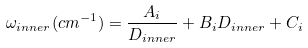Convert formula to latex. <formula><loc_0><loc_0><loc_500><loc_500>\omega _ { i n n e r } ( c m ^ { - 1 } ) = \frac { A _ { i } } { D _ { i n n e r } } + B _ { i } D _ { i n n e r } + C _ { i }</formula> 